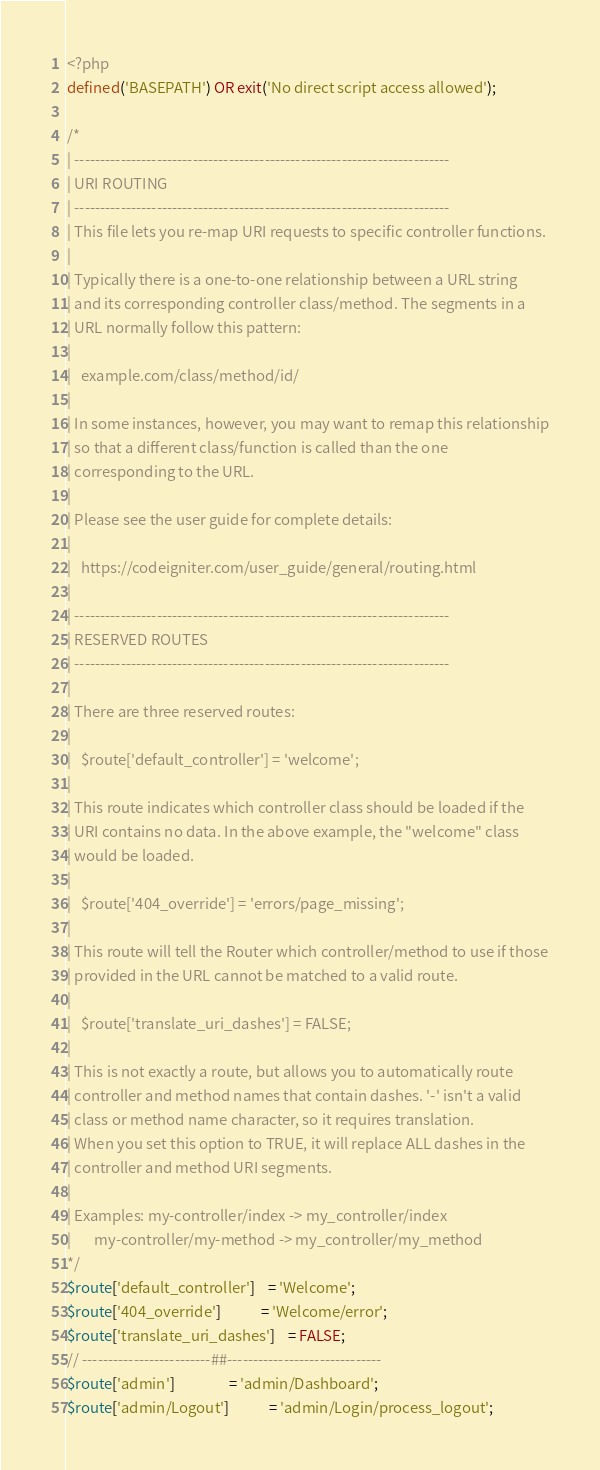Convert code to text. <code><loc_0><loc_0><loc_500><loc_500><_PHP_><?php
defined('BASEPATH') OR exit('No direct script access allowed');

/*
| -------------------------------------------------------------------------
| URI ROUTING
| -------------------------------------------------------------------------
| This file lets you re-map URI requests to specific controller functions.
|
| Typically there is a one-to-one relationship between a URL string
| and its corresponding controller class/method. The segments in a
| URL normally follow this pattern:
|
|	example.com/class/method/id/
|
| In some instances, however, you may want to remap this relationship
| so that a different class/function is called than the one
| corresponding to the URL.
|
| Please see the user guide for complete details:
|
|	https://codeigniter.com/user_guide/general/routing.html
|
| -------------------------------------------------------------------------
| RESERVED ROUTES
| -------------------------------------------------------------------------
|
| There are three reserved routes:
|
|	$route['default_controller'] = 'welcome';
|
| This route indicates which controller class should be loaded if the
| URI contains no data. In the above example, the "welcome" class
| would be loaded.
|
|	$route['404_override'] = 'errors/page_missing';
|
| This route will tell the Router which controller/method to use if those
| provided in the URL cannot be matched to a valid route.
|
|	$route['translate_uri_dashes'] = FALSE;
|
| This is not exactly a route, but allows you to automatically route
| controller and method names that contain dashes. '-' isn't a valid
| class or method name character, so it requires translation.
| When you set this option to TRUE, it will replace ALL dashes in the
| controller and method URI segments.
|
| Examples:	my-controller/index	-> my_controller/index
|		my-controller/my-method	-> my_controller/my_method
*/
$route['default_controller'] 	= 'Welcome';
$route['404_override'] 			= 'Welcome/error';
$route['translate_uri_dashes'] 	= FALSE;
// -------------------------##------------------------------
$route['admin'] 				= 'admin/Dashboard';
$route['admin/Logout'] 			= 'admin/Login/process_logout';
</code> 